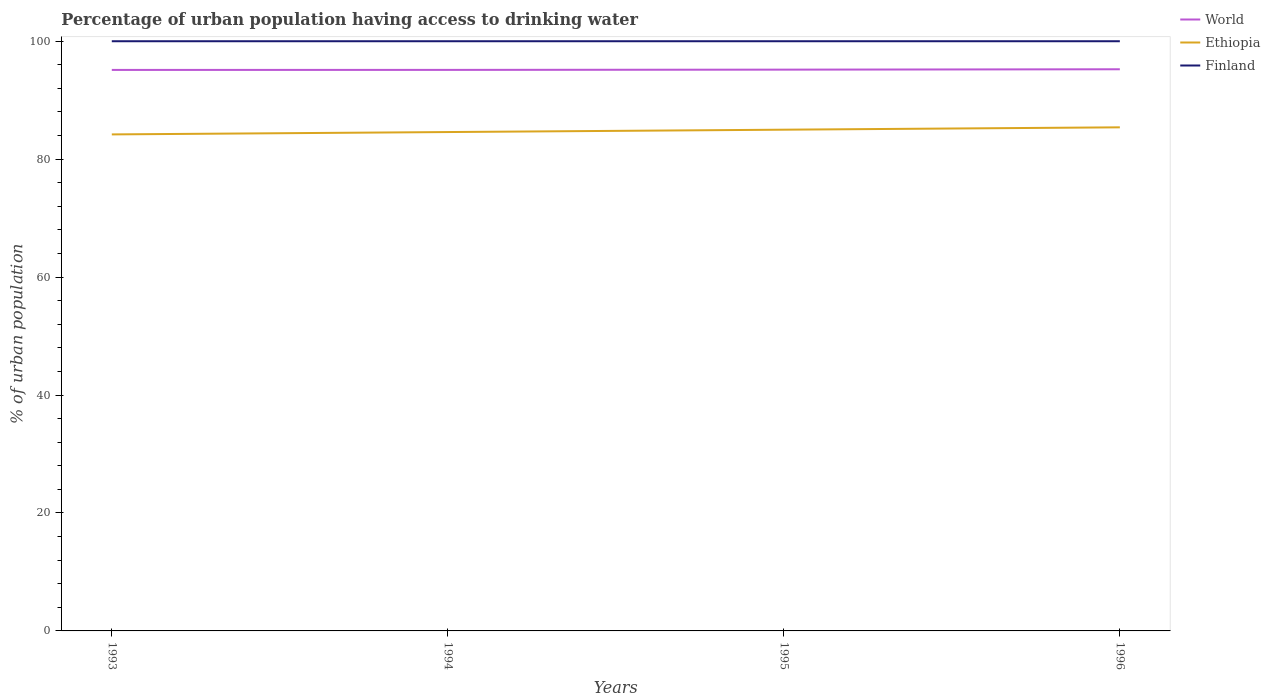How many different coloured lines are there?
Offer a terse response. 3. Is the number of lines equal to the number of legend labels?
Provide a succinct answer. Yes. Across all years, what is the maximum percentage of urban population having access to drinking water in Finland?
Your response must be concise. 100. In which year was the percentage of urban population having access to drinking water in Ethiopia maximum?
Your answer should be compact. 1993. What is the total percentage of urban population having access to drinking water in Ethiopia in the graph?
Offer a very short reply. -0.8. What is the difference between the highest and the second highest percentage of urban population having access to drinking water in Ethiopia?
Offer a terse response. 1.2. Is the percentage of urban population having access to drinking water in Ethiopia strictly greater than the percentage of urban population having access to drinking water in World over the years?
Make the answer very short. Yes. How many years are there in the graph?
Your answer should be very brief. 4. What is the difference between two consecutive major ticks on the Y-axis?
Make the answer very short. 20. Does the graph contain any zero values?
Provide a succinct answer. No. How many legend labels are there?
Offer a very short reply. 3. What is the title of the graph?
Your response must be concise. Percentage of urban population having access to drinking water. What is the label or title of the Y-axis?
Give a very brief answer. % of urban population. What is the % of urban population of World in 1993?
Provide a succinct answer. 95.13. What is the % of urban population of Ethiopia in 1993?
Provide a short and direct response. 84.2. What is the % of urban population in World in 1994?
Your answer should be compact. 95.14. What is the % of urban population of Ethiopia in 1994?
Your response must be concise. 84.6. What is the % of urban population of World in 1995?
Your response must be concise. 95.18. What is the % of urban population in Ethiopia in 1995?
Offer a very short reply. 85. What is the % of urban population of World in 1996?
Provide a succinct answer. 95.25. What is the % of urban population in Ethiopia in 1996?
Your response must be concise. 85.4. Across all years, what is the maximum % of urban population in World?
Keep it short and to the point. 95.25. Across all years, what is the maximum % of urban population of Ethiopia?
Offer a very short reply. 85.4. Across all years, what is the minimum % of urban population in World?
Provide a short and direct response. 95.13. Across all years, what is the minimum % of urban population of Ethiopia?
Offer a terse response. 84.2. What is the total % of urban population of World in the graph?
Your answer should be very brief. 380.7. What is the total % of urban population of Ethiopia in the graph?
Make the answer very short. 339.2. What is the difference between the % of urban population of World in 1993 and that in 1994?
Give a very brief answer. -0.01. What is the difference between the % of urban population in Ethiopia in 1993 and that in 1994?
Keep it short and to the point. -0.4. What is the difference between the % of urban population in World in 1993 and that in 1995?
Offer a very short reply. -0.05. What is the difference between the % of urban population in Finland in 1993 and that in 1995?
Offer a very short reply. 0. What is the difference between the % of urban population in World in 1993 and that in 1996?
Offer a very short reply. -0.11. What is the difference between the % of urban population of Ethiopia in 1993 and that in 1996?
Keep it short and to the point. -1.2. What is the difference between the % of urban population of Finland in 1993 and that in 1996?
Your answer should be very brief. 0. What is the difference between the % of urban population in World in 1994 and that in 1995?
Provide a succinct answer. -0.04. What is the difference between the % of urban population in World in 1994 and that in 1996?
Offer a very short reply. -0.11. What is the difference between the % of urban population of World in 1995 and that in 1996?
Give a very brief answer. -0.06. What is the difference between the % of urban population in World in 1993 and the % of urban population in Ethiopia in 1994?
Keep it short and to the point. 10.53. What is the difference between the % of urban population in World in 1993 and the % of urban population in Finland in 1994?
Provide a succinct answer. -4.87. What is the difference between the % of urban population of Ethiopia in 1993 and the % of urban population of Finland in 1994?
Give a very brief answer. -15.8. What is the difference between the % of urban population in World in 1993 and the % of urban population in Ethiopia in 1995?
Offer a terse response. 10.13. What is the difference between the % of urban population in World in 1993 and the % of urban population in Finland in 1995?
Make the answer very short. -4.87. What is the difference between the % of urban population of Ethiopia in 1993 and the % of urban population of Finland in 1995?
Make the answer very short. -15.8. What is the difference between the % of urban population in World in 1993 and the % of urban population in Ethiopia in 1996?
Provide a short and direct response. 9.73. What is the difference between the % of urban population in World in 1993 and the % of urban population in Finland in 1996?
Make the answer very short. -4.87. What is the difference between the % of urban population of Ethiopia in 1993 and the % of urban population of Finland in 1996?
Give a very brief answer. -15.8. What is the difference between the % of urban population in World in 1994 and the % of urban population in Ethiopia in 1995?
Give a very brief answer. 10.14. What is the difference between the % of urban population of World in 1994 and the % of urban population of Finland in 1995?
Keep it short and to the point. -4.86. What is the difference between the % of urban population in Ethiopia in 1994 and the % of urban population in Finland in 1995?
Offer a terse response. -15.4. What is the difference between the % of urban population of World in 1994 and the % of urban population of Ethiopia in 1996?
Your answer should be compact. 9.74. What is the difference between the % of urban population in World in 1994 and the % of urban population in Finland in 1996?
Ensure brevity in your answer.  -4.86. What is the difference between the % of urban population of Ethiopia in 1994 and the % of urban population of Finland in 1996?
Provide a succinct answer. -15.4. What is the difference between the % of urban population in World in 1995 and the % of urban population in Ethiopia in 1996?
Provide a succinct answer. 9.78. What is the difference between the % of urban population of World in 1995 and the % of urban population of Finland in 1996?
Keep it short and to the point. -4.82. What is the difference between the % of urban population in Ethiopia in 1995 and the % of urban population in Finland in 1996?
Your answer should be compact. -15. What is the average % of urban population in World per year?
Offer a terse response. 95.18. What is the average % of urban population in Ethiopia per year?
Ensure brevity in your answer.  84.8. In the year 1993, what is the difference between the % of urban population in World and % of urban population in Ethiopia?
Provide a succinct answer. 10.93. In the year 1993, what is the difference between the % of urban population of World and % of urban population of Finland?
Ensure brevity in your answer.  -4.87. In the year 1993, what is the difference between the % of urban population in Ethiopia and % of urban population in Finland?
Offer a terse response. -15.8. In the year 1994, what is the difference between the % of urban population in World and % of urban population in Ethiopia?
Your response must be concise. 10.54. In the year 1994, what is the difference between the % of urban population in World and % of urban population in Finland?
Offer a very short reply. -4.86. In the year 1994, what is the difference between the % of urban population of Ethiopia and % of urban population of Finland?
Offer a very short reply. -15.4. In the year 1995, what is the difference between the % of urban population of World and % of urban population of Ethiopia?
Provide a succinct answer. 10.18. In the year 1995, what is the difference between the % of urban population in World and % of urban population in Finland?
Offer a terse response. -4.82. In the year 1995, what is the difference between the % of urban population of Ethiopia and % of urban population of Finland?
Provide a succinct answer. -15. In the year 1996, what is the difference between the % of urban population in World and % of urban population in Ethiopia?
Keep it short and to the point. 9.85. In the year 1996, what is the difference between the % of urban population in World and % of urban population in Finland?
Keep it short and to the point. -4.75. In the year 1996, what is the difference between the % of urban population of Ethiopia and % of urban population of Finland?
Provide a succinct answer. -14.6. What is the ratio of the % of urban population of World in 1993 to that in 1994?
Offer a terse response. 1. What is the ratio of the % of urban population in Finland in 1993 to that in 1994?
Offer a very short reply. 1. What is the ratio of the % of urban population in Ethiopia in 1993 to that in 1995?
Provide a short and direct response. 0.99. What is the ratio of the % of urban population of Finland in 1993 to that in 1995?
Provide a succinct answer. 1. What is the ratio of the % of urban population in World in 1993 to that in 1996?
Ensure brevity in your answer.  1. What is the ratio of the % of urban population of Ethiopia in 1993 to that in 1996?
Your answer should be compact. 0.99. What is the ratio of the % of urban population of Finland in 1993 to that in 1996?
Provide a short and direct response. 1. What is the ratio of the % of urban population in Finland in 1994 to that in 1995?
Offer a very short reply. 1. What is the ratio of the % of urban population in Ethiopia in 1994 to that in 1996?
Provide a succinct answer. 0.99. What is the ratio of the % of urban population of World in 1995 to that in 1996?
Provide a succinct answer. 1. What is the difference between the highest and the second highest % of urban population in World?
Provide a short and direct response. 0.06. What is the difference between the highest and the second highest % of urban population of Ethiopia?
Provide a short and direct response. 0.4. What is the difference between the highest and the lowest % of urban population in World?
Make the answer very short. 0.11. What is the difference between the highest and the lowest % of urban population of Finland?
Offer a terse response. 0. 